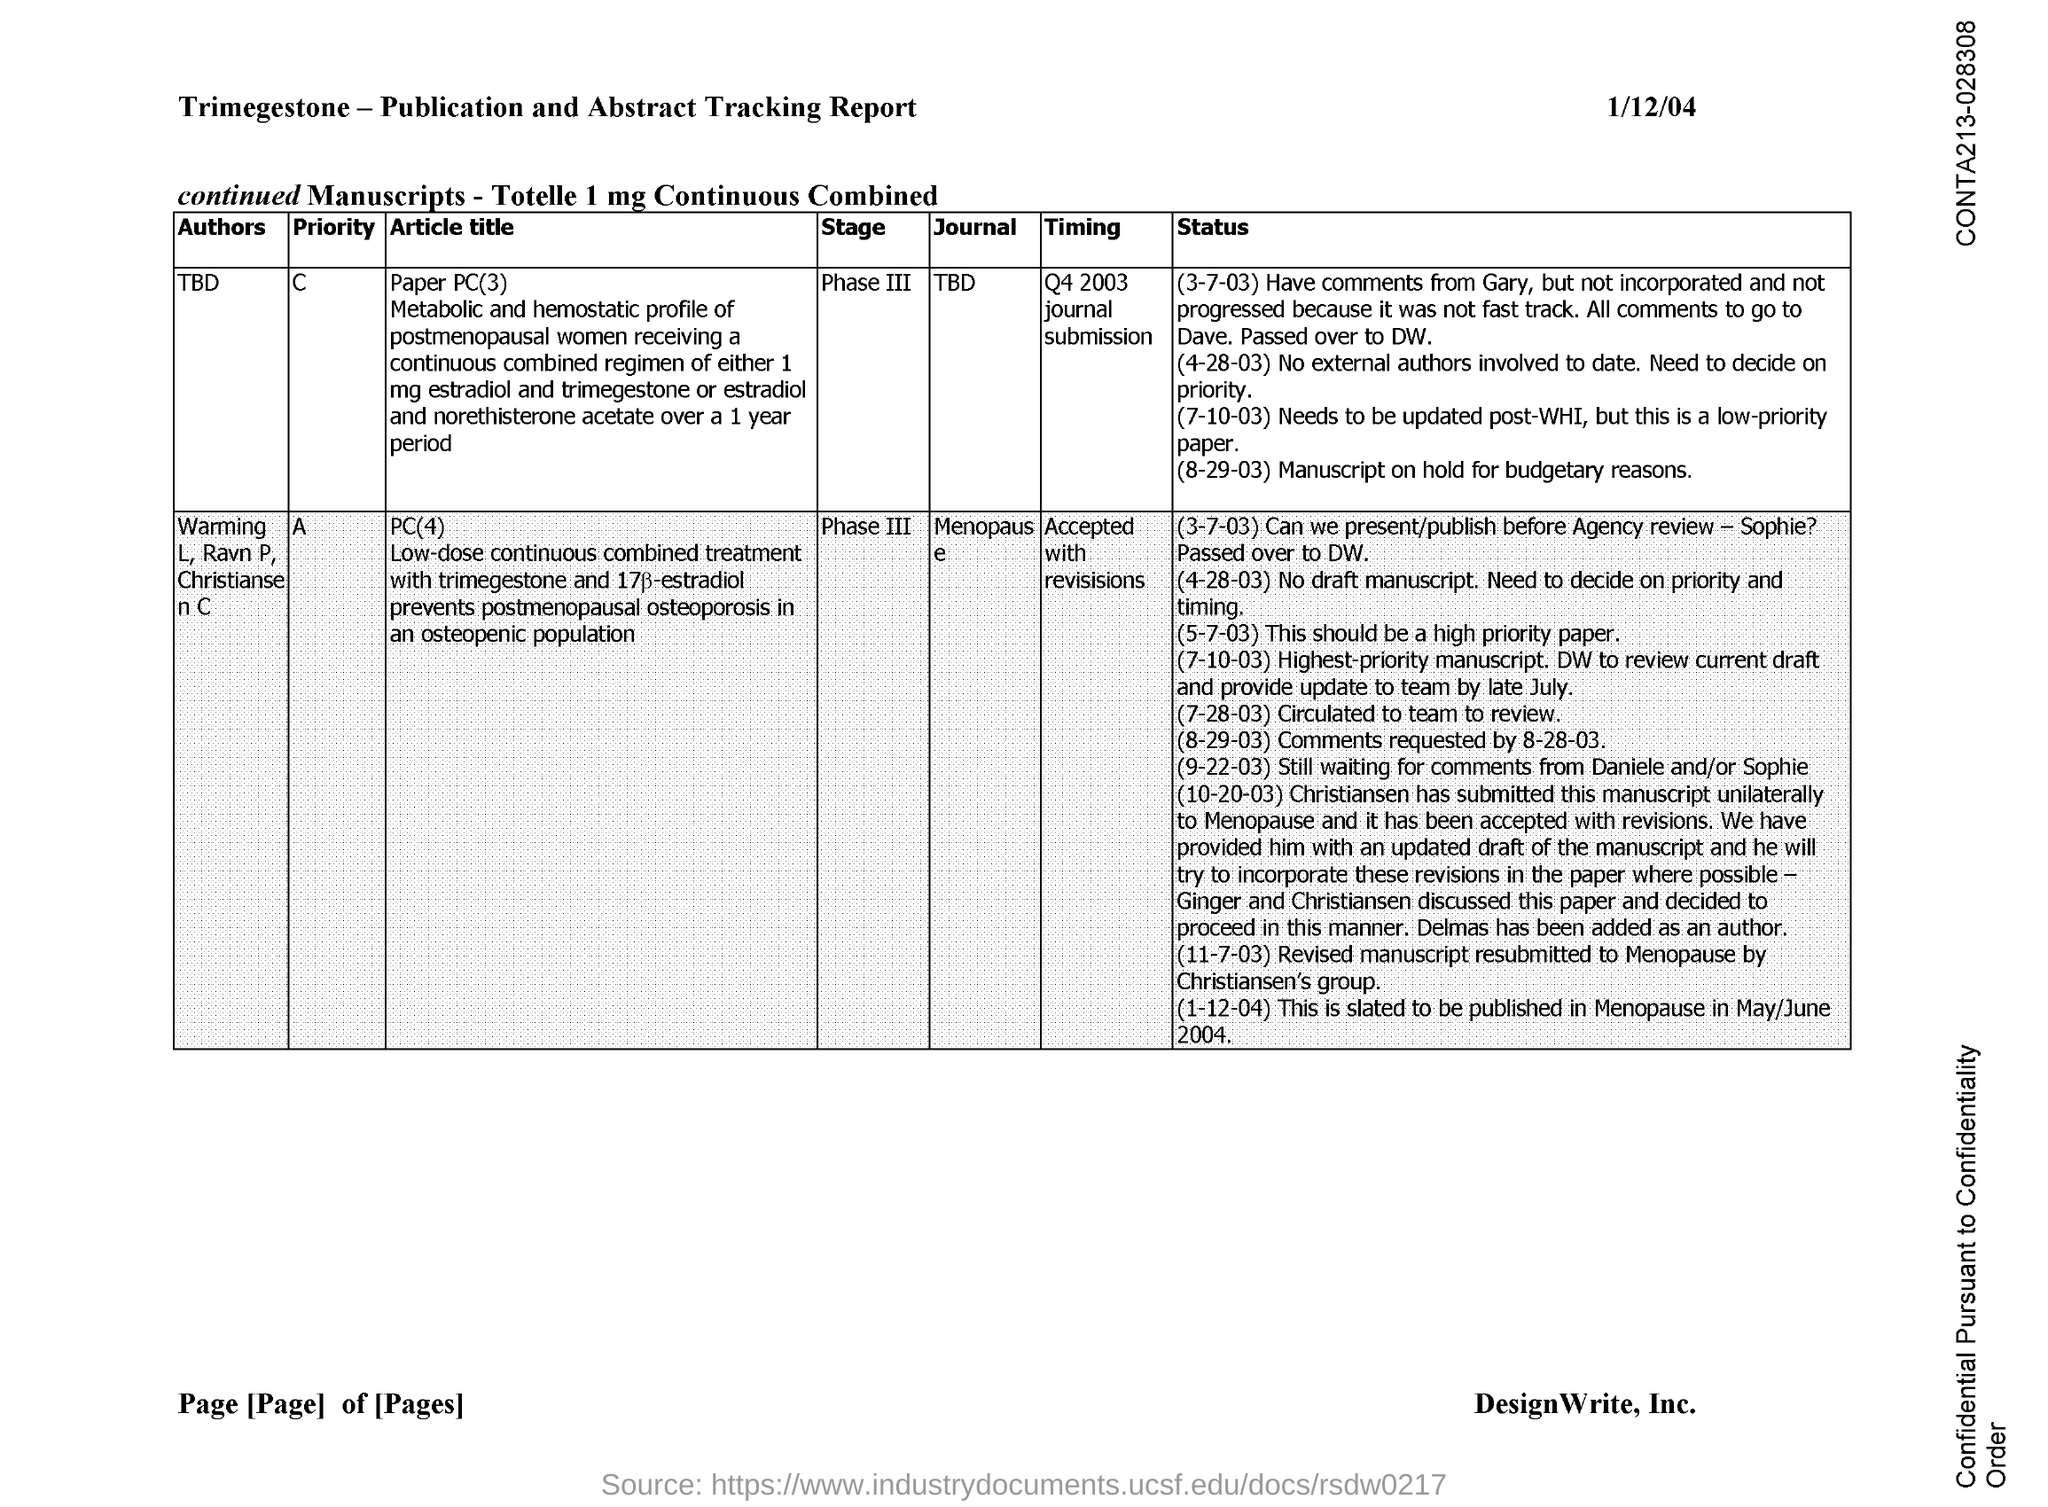What is the date on the document?
Make the answer very short. 1/12/04. 